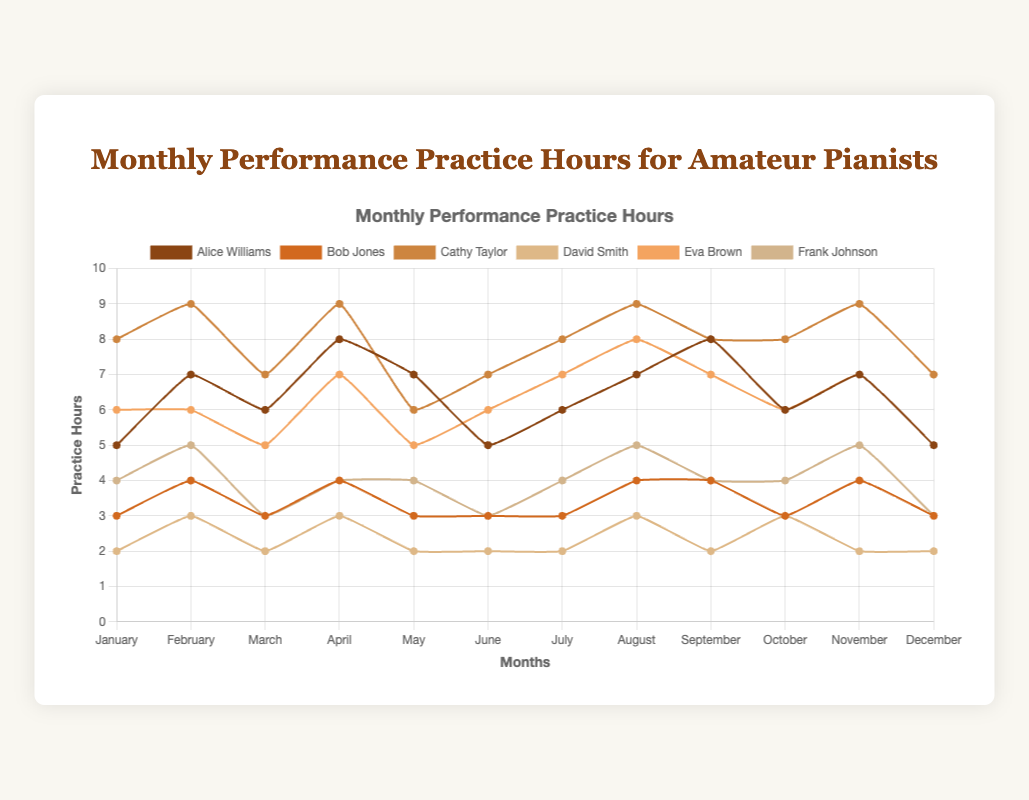Which pianist practiced the most in March? Looking at the line plot, we can compare the practice hours in March for all pianists. Cathy Taylor has the highest practice hours with 7 hours.
Answer: Cathy Taylor How many total practice hours did Bob Jones have in the first quarter of the year (January to March)? To find Bob Jones' total practice hours in the first quarter, sum the hours from January, February, and March: 3 + 4 + 3 = 10 hours.
Answer: 10 Which month did Eva Brown practice the least? By checking Eva Brown’s line across the months, the lowest practice hours are observed in March with 5 hours.
Answer: March Who had more practice hours in June: Alice Williams or Frank Johnson? Comparing the line plot for June, Alice Williams practiced for 5 hours, while Frank Johnson practiced for 3 hours.
Answer: Alice Williams In which month did Alice Williams and Bob Jones have the same number of practice hours? Scan the lines for Alice Williams and Bob Jones to find months where their hours overlap. In February, both have 7 and 4 hours respectively, showing they never have the same practice hour. Therefore, no months have equal hours.
Answer: None What's the average monthly practice hours for Cathy Taylor? To calculate the average monthly practice hours for Cathy Taylor, sum all the hours and divide by 12: (8 + 9 + 7 + 9 + 6 + 7 + 8 + 9 + 8 + 8 + 9 + 7) / 12 = 8 hours.
Answer: 8 In which months did Alice Williams' practice hours exceed those of Eva Brown? Comparing Alice Williams’ and Eva Brown’s lines, we find that Alice practiced more in April (8 vs. 7), and September (8 vs. 7).
Answer: April, September Who reduced their practice hours the most from July to August? By observing the lines for the difference between July and August practice hours, Bob Jones decreased by 1 hour (4 to 3). David Smith shows the same difference. Further analysis for comparison is needed. Hence, both Bob Jones and David Smith share the maximum reduction.
Answer: Bob_Jones, David_Smith's reduction is same What is the difference between the highest and lowest practice hours for Frank Johnson? Frank Johnson's highest practice hours are 5 (February, August, and November), and the lowest is 3 (March, June, and December), the difference: 5 - 3 = 2 hours.
Answer: 2 